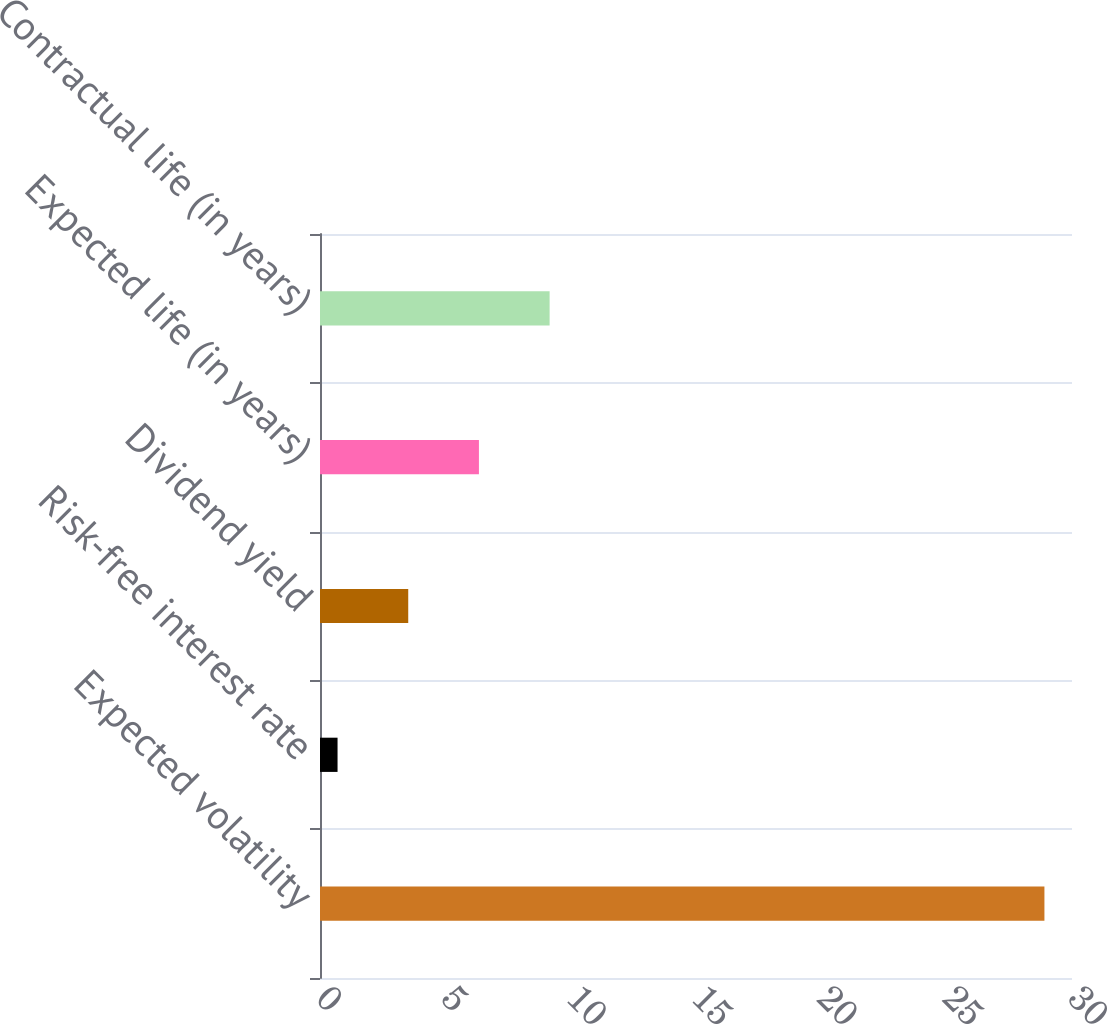<chart> <loc_0><loc_0><loc_500><loc_500><bar_chart><fcel>Expected volatility<fcel>Risk-free interest rate<fcel>Dividend yield<fcel>Expected life (in years)<fcel>Contractual life (in years)<nl><fcel>28.9<fcel>0.7<fcel>3.52<fcel>6.34<fcel>9.16<nl></chart> 